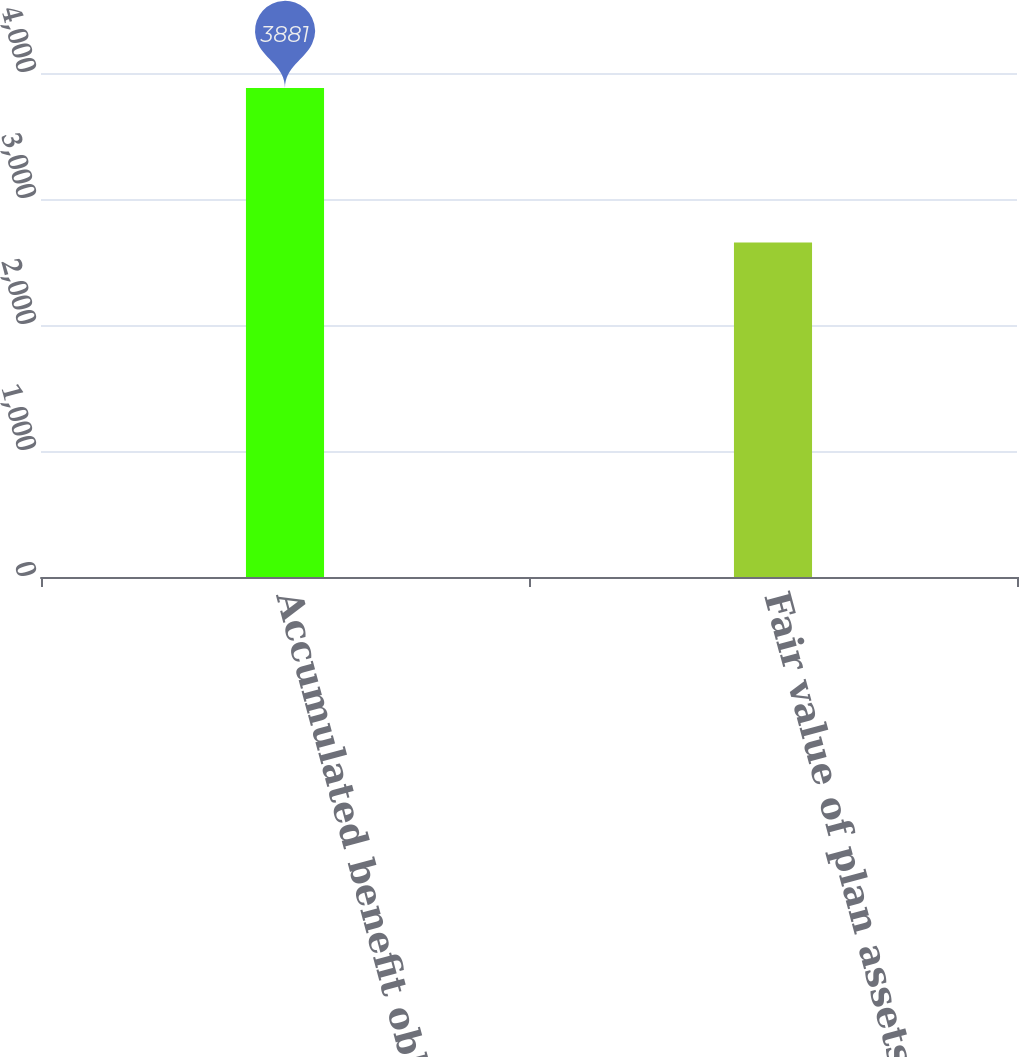<chart> <loc_0><loc_0><loc_500><loc_500><bar_chart><fcel>Accumulated benefit obligation<fcel>Fair value of plan assets<nl><fcel>3881<fcel>2654<nl></chart> 